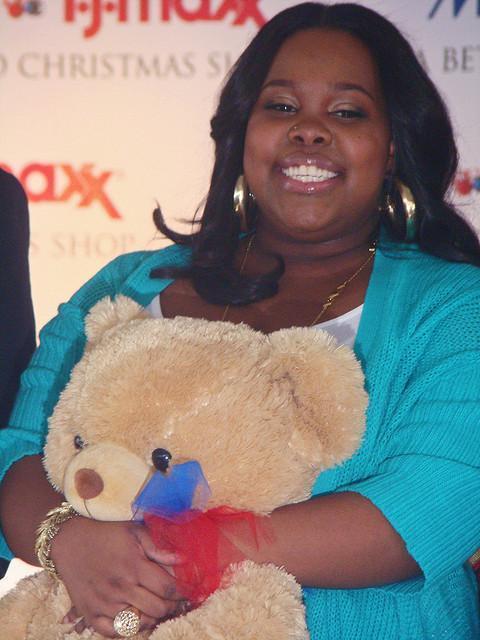Verify the accuracy of this image caption: "The teddy bear is touching the person.".
Answer yes or no. Yes. Is the given caption "The person is at the right side of the teddy bear." fitting for the image?
Answer yes or no. No. 